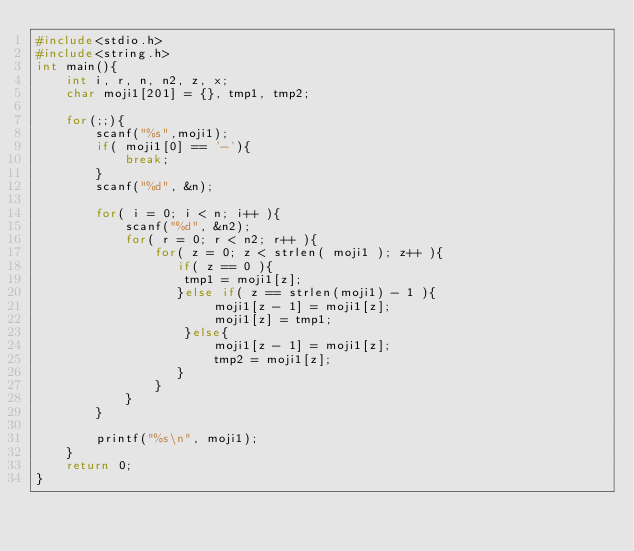Convert code to text. <code><loc_0><loc_0><loc_500><loc_500><_C_>#include<stdio.h>
#include<string.h>
int main(){
    int i, r, n, n2, z, x;
    char moji1[201] = {}, tmp1, tmp2;

    for(;;){
        scanf("%s",moji1);
        if( moji1[0] == '-'){
            break;
        }
        scanf("%d", &n);

        for( i = 0; i < n; i++ ){
            scanf("%d", &n2);
            for( r = 0; r < n2; r++ ){
                for( z = 0; z < strlen( moji1 ); z++ ){
                   if( z == 0 ){
                    tmp1 = moji1[z];
                   }else if( z == strlen(moji1) - 1 ){
                        moji1[z - 1] = moji1[z];
                        moji1[z] = tmp1;
                    }else{
                        moji1[z - 1] = moji1[z];
                        tmp2 = moji1[z];
                   }
                }
            }
        }

        printf("%s\n", moji1);
    }
    return 0;
}</code> 